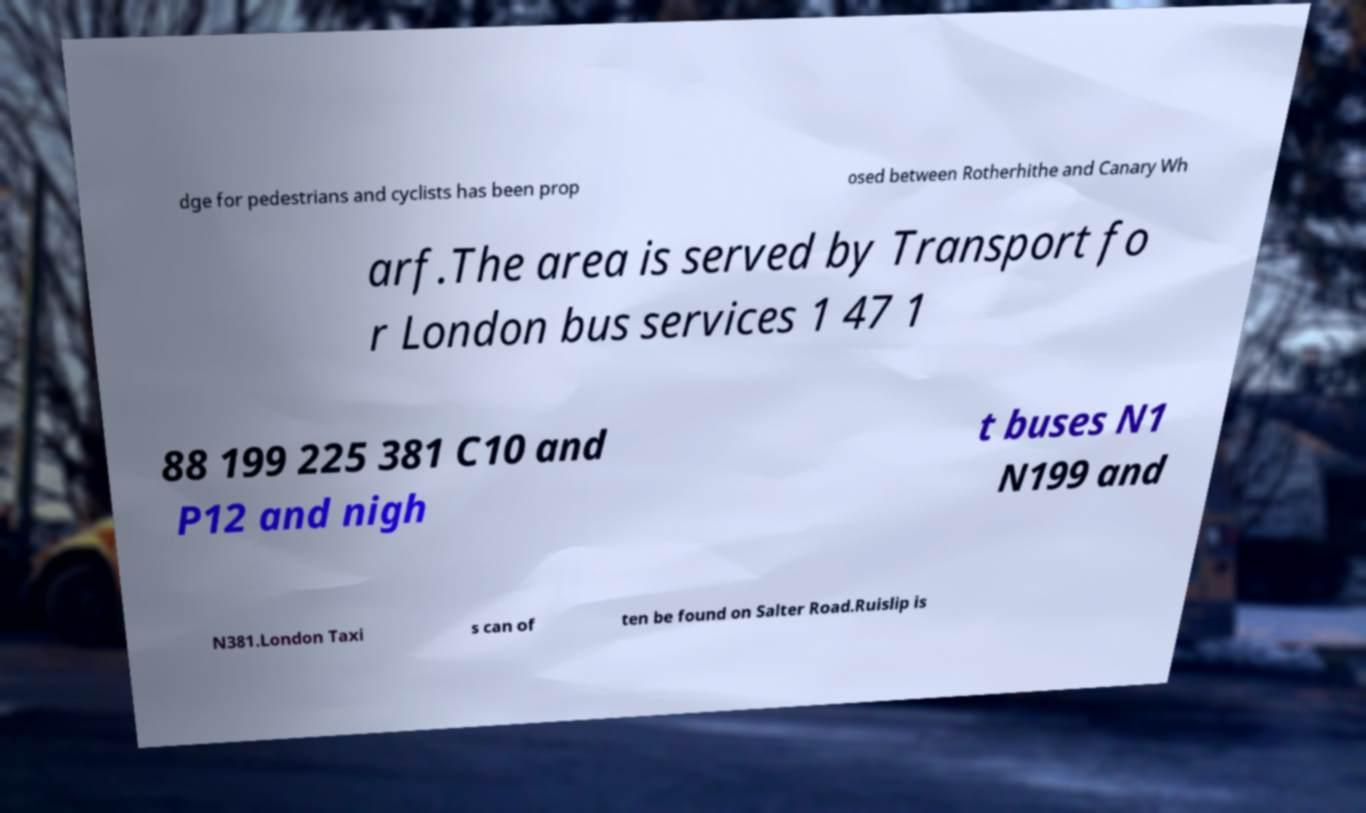Please read and relay the text visible in this image. What does it say? dge for pedestrians and cyclists has been prop osed between Rotherhithe and Canary Wh arf.The area is served by Transport fo r London bus services 1 47 1 88 199 225 381 C10 and P12 and nigh t buses N1 N199 and N381.London Taxi s can of ten be found on Salter Road.Ruislip is 